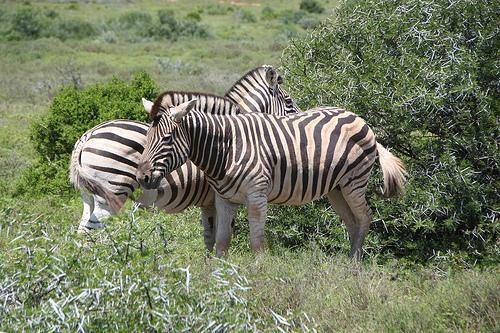How many zebras are in the photo?
Give a very brief answer. 2. 